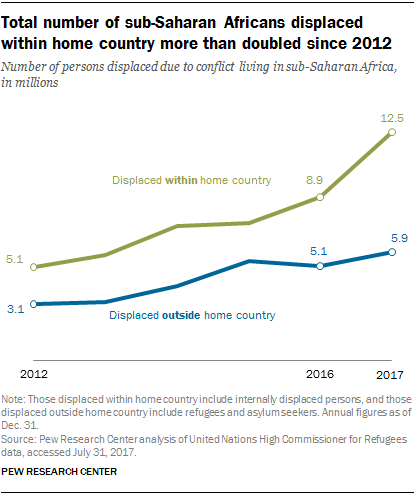Draw attention to some important aspects in this diagram. The sum of the median and lowest value of the blue graph is 8.2. The rightmost value of the "green" graph is 12.5. Yes. 